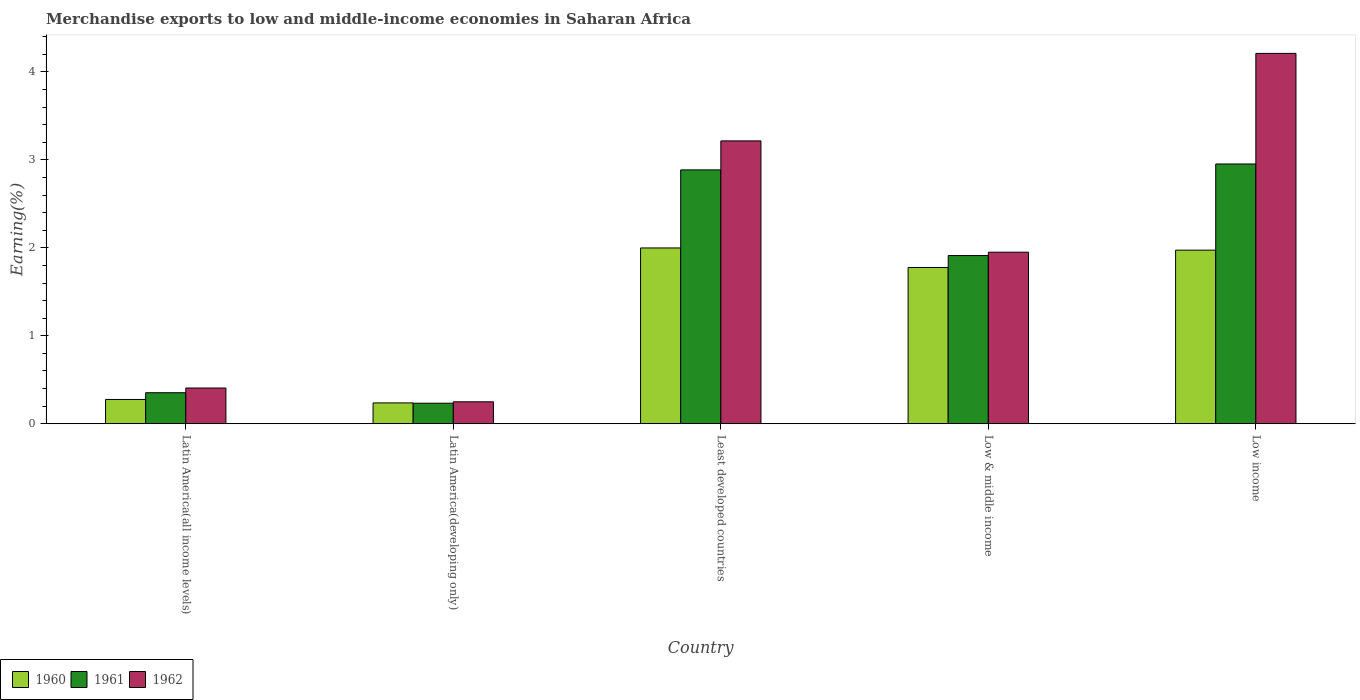How many different coloured bars are there?
Your answer should be very brief. 3. Are the number of bars on each tick of the X-axis equal?
Ensure brevity in your answer.  Yes. What is the label of the 1st group of bars from the left?
Provide a short and direct response. Latin America(all income levels). What is the percentage of amount earned from merchandise exports in 1962 in Least developed countries?
Keep it short and to the point. 3.22. Across all countries, what is the maximum percentage of amount earned from merchandise exports in 1962?
Ensure brevity in your answer.  4.21. Across all countries, what is the minimum percentage of amount earned from merchandise exports in 1960?
Your answer should be compact. 0.24. In which country was the percentage of amount earned from merchandise exports in 1962 maximum?
Ensure brevity in your answer.  Low income. In which country was the percentage of amount earned from merchandise exports in 1960 minimum?
Ensure brevity in your answer.  Latin America(developing only). What is the total percentage of amount earned from merchandise exports in 1960 in the graph?
Offer a very short reply. 6.26. What is the difference between the percentage of amount earned from merchandise exports in 1961 in Latin America(all income levels) and that in Low income?
Your response must be concise. -2.6. What is the difference between the percentage of amount earned from merchandise exports in 1961 in Least developed countries and the percentage of amount earned from merchandise exports in 1962 in Low & middle income?
Your response must be concise. 0.94. What is the average percentage of amount earned from merchandise exports in 1961 per country?
Offer a very short reply. 1.67. What is the difference between the percentage of amount earned from merchandise exports of/in 1961 and percentage of amount earned from merchandise exports of/in 1960 in Least developed countries?
Your answer should be very brief. 0.89. What is the ratio of the percentage of amount earned from merchandise exports in 1960 in Latin America(all income levels) to that in Low income?
Offer a very short reply. 0.14. Is the percentage of amount earned from merchandise exports in 1961 in Latin America(all income levels) less than that in Low & middle income?
Make the answer very short. Yes. What is the difference between the highest and the second highest percentage of amount earned from merchandise exports in 1962?
Your answer should be very brief. -1.27. What is the difference between the highest and the lowest percentage of amount earned from merchandise exports in 1961?
Your response must be concise. 2.72. Is the sum of the percentage of amount earned from merchandise exports in 1961 in Latin America(all income levels) and Low income greater than the maximum percentage of amount earned from merchandise exports in 1960 across all countries?
Ensure brevity in your answer.  Yes. What does the 3rd bar from the left in Latin America(developing only) represents?
Offer a terse response. 1962. Is it the case that in every country, the sum of the percentage of amount earned from merchandise exports in 1960 and percentage of amount earned from merchandise exports in 1962 is greater than the percentage of amount earned from merchandise exports in 1961?
Keep it short and to the point. Yes. Are all the bars in the graph horizontal?
Ensure brevity in your answer.  No. Does the graph contain any zero values?
Your answer should be very brief. No. What is the title of the graph?
Your response must be concise. Merchandise exports to low and middle-income economies in Saharan Africa. Does "1989" appear as one of the legend labels in the graph?
Make the answer very short. No. What is the label or title of the X-axis?
Keep it short and to the point. Country. What is the label or title of the Y-axis?
Ensure brevity in your answer.  Earning(%). What is the Earning(%) of 1960 in Latin America(all income levels)?
Provide a short and direct response. 0.28. What is the Earning(%) of 1961 in Latin America(all income levels)?
Offer a very short reply. 0.35. What is the Earning(%) in 1962 in Latin America(all income levels)?
Your response must be concise. 0.41. What is the Earning(%) of 1960 in Latin America(developing only)?
Ensure brevity in your answer.  0.24. What is the Earning(%) in 1961 in Latin America(developing only)?
Provide a short and direct response. 0.23. What is the Earning(%) in 1962 in Latin America(developing only)?
Keep it short and to the point. 0.25. What is the Earning(%) of 1960 in Least developed countries?
Offer a terse response. 2. What is the Earning(%) of 1961 in Least developed countries?
Provide a succinct answer. 2.89. What is the Earning(%) of 1962 in Least developed countries?
Ensure brevity in your answer.  3.22. What is the Earning(%) in 1960 in Low & middle income?
Your answer should be very brief. 1.78. What is the Earning(%) in 1961 in Low & middle income?
Provide a succinct answer. 1.91. What is the Earning(%) in 1962 in Low & middle income?
Provide a succinct answer. 1.95. What is the Earning(%) in 1960 in Low income?
Your answer should be very brief. 1.97. What is the Earning(%) in 1961 in Low income?
Ensure brevity in your answer.  2.95. What is the Earning(%) of 1962 in Low income?
Provide a succinct answer. 4.21. Across all countries, what is the maximum Earning(%) of 1960?
Provide a succinct answer. 2. Across all countries, what is the maximum Earning(%) of 1961?
Provide a short and direct response. 2.95. Across all countries, what is the maximum Earning(%) in 1962?
Your answer should be compact. 4.21. Across all countries, what is the minimum Earning(%) in 1960?
Your answer should be very brief. 0.24. Across all countries, what is the minimum Earning(%) of 1961?
Ensure brevity in your answer.  0.23. Across all countries, what is the minimum Earning(%) of 1962?
Ensure brevity in your answer.  0.25. What is the total Earning(%) in 1960 in the graph?
Your answer should be very brief. 6.26. What is the total Earning(%) of 1961 in the graph?
Provide a short and direct response. 8.34. What is the total Earning(%) of 1962 in the graph?
Make the answer very short. 10.03. What is the difference between the Earning(%) in 1960 in Latin America(all income levels) and that in Latin America(developing only)?
Your answer should be compact. 0.04. What is the difference between the Earning(%) in 1961 in Latin America(all income levels) and that in Latin America(developing only)?
Offer a terse response. 0.12. What is the difference between the Earning(%) in 1962 in Latin America(all income levels) and that in Latin America(developing only)?
Your answer should be compact. 0.16. What is the difference between the Earning(%) of 1960 in Latin America(all income levels) and that in Least developed countries?
Provide a short and direct response. -1.72. What is the difference between the Earning(%) of 1961 in Latin America(all income levels) and that in Least developed countries?
Your answer should be very brief. -2.53. What is the difference between the Earning(%) in 1962 in Latin America(all income levels) and that in Least developed countries?
Provide a succinct answer. -2.81. What is the difference between the Earning(%) in 1960 in Latin America(all income levels) and that in Low & middle income?
Your answer should be compact. -1.5. What is the difference between the Earning(%) of 1961 in Latin America(all income levels) and that in Low & middle income?
Ensure brevity in your answer.  -1.56. What is the difference between the Earning(%) of 1962 in Latin America(all income levels) and that in Low & middle income?
Your response must be concise. -1.54. What is the difference between the Earning(%) in 1960 in Latin America(all income levels) and that in Low income?
Keep it short and to the point. -1.7. What is the difference between the Earning(%) in 1961 in Latin America(all income levels) and that in Low income?
Provide a short and direct response. -2.6. What is the difference between the Earning(%) in 1962 in Latin America(all income levels) and that in Low income?
Keep it short and to the point. -3.8. What is the difference between the Earning(%) in 1960 in Latin America(developing only) and that in Least developed countries?
Offer a terse response. -1.76. What is the difference between the Earning(%) in 1961 in Latin America(developing only) and that in Least developed countries?
Your response must be concise. -2.65. What is the difference between the Earning(%) of 1962 in Latin America(developing only) and that in Least developed countries?
Give a very brief answer. -2.97. What is the difference between the Earning(%) of 1960 in Latin America(developing only) and that in Low & middle income?
Your answer should be compact. -1.54. What is the difference between the Earning(%) in 1961 in Latin America(developing only) and that in Low & middle income?
Give a very brief answer. -1.68. What is the difference between the Earning(%) of 1962 in Latin America(developing only) and that in Low & middle income?
Provide a succinct answer. -1.7. What is the difference between the Earning(%) in 1960 in Latin America(developing only) and that in Low income?
Your answer should be very brief. -1.74. What is the difference between the Earning(%) in 1961 in Latin America(developing only) and that in Low income?
Your answer should be compact. -2.72. What is the difference between the Earning(%) in 1962 in Latin America(developing only) and that in Low income?
Offer a very short reply. -3.96. What is the difference between the Earning(%) in 1960 in Least developed countries and that in Low & middle income?
Offer a very short reply. 0.22. What is the difference between the Earning(%) of 1961 in Least developed countries and that in Low & middle income?
Provide a succinct answer. 0.97. What is the difference between the Earning(%) in 1962 in Least developed countries and that in Low & middle income?
Make the answer very short. 1.27. What is the difference between the Earning(%) in 1960 in Least developed countries and that in Low income?
Provide a short and direct response. 0.03. What is the difference between the Earning(%) of 1961 in Least developed countries and that in Low income?
Provide a succinct answer. -0.07. What is the difference between the Earning(%) of 1962 in Least developed countries and that in Low income?
Provide a succinct answer. -0.99. What is the difference between the Earning(%) of 1960 in Low & middle income and that in Low income?
Offer a very short reply. -0.2. What is the difference between the Earning(%) of 1961 in Low & middle income and that in Low income?
Keep it short and to the point. -1.04. What is the difference between the Earning(%) in 1962 in Low & middle income and that in Low income?
Offer a terse response. -2.26. What is the difference between the Earning(%) in 1960 in Latin America(all income levels) and the Earning(%) in 1961 in Latin America(developing only)?
Your answer should be compact. 0.04. What is the difference between the Earning(%) of 1960 in Latin America(all income levels) and the Earning(%) of 1962 in Latin America(developing only)?
Ensure brevity in your answer.  0.03. What is the difference between the Earning(%) in 1961 in Latin America(all income levels) and the Earning(%) in 1962 in Latin America(developing only)?
Ensure brevity in your answer.  0.1. What is the difference between the Earning(%) of 1960 in Latin America(all income levels) and the Earning(%) of 1961 in Least developed countries?
Offer a terse response. -2.61. What is the difference between the Earning(%) of 1960 in Latin America(all income levels) and the Earning(%) of 1962 in Least developed countries?
Your response must be concise. -2.94. What is the difference between the Earning(%) of 1961 in Latin America(all income levels) and the Earning(%) of 1962 in Least developed countries?
Provide a succinct answer. -2.86. What is the difference between the Earning(%) in 1960 in Latin America(all income levels) and the Earning(%) in 1961 in Low & middle income?
Your answer should be compact. -1.64. What is the difference between the Earning(%) of 1960 in Latin America(all income levels) and the Earning(%) of 1962 in Low & middle income?
Provide a short and direct response. -1.67. What is the difference between the Earning(%) of 1961 in Latin America(all income levels) and the Earning(%) of 1962 in Low & middle income?
Your response must be concise. -1.6. What is the difference between the Earning(%) of 1960 in Latin America(all income levels) and the Earning(%) of 1961 in Low income?
Give a very brief answer. -2.68. What is the difference between the Earning(%) in 1960 in Latin America(all income levels) and the Earning(%) in 1962 in Low income?
Make the answer very short. -3.94. What is the difference between the Earning(%) of 1961 in Latin America(all income levels) and the Earning(%) of 1962 in Low income?
Your answer should be compact. -3.86. What is the difference between the Earning(%) in 1960 in Latin America(developing only) and the Earning(%) in 1961 in Least developed countries?
Provide a short and direct response. -2.65. What is the difference between the Earning(%) of 1960 in Latin America(developing only) and the Earning(%) of 1962 in Least developed countries?
Make the answer very short. -2.98. What is the difference between the Earning(%) in 1961 in Latin America(developing only) and the Earning(%) in 1962 in Least developed countries?
Your answer should be very brief. -2.98. What is the difference between the Earning(%) in 1960 in Latin America(developing only) and the Earning(%) in 1961 in Low & middle income?
Give a very brief answer. -1.68. What is the difference between the Earning(%) in 1960 in Latin America(developing only) and the Earning(%) in 1962 in Low & middle income?
Your answer should be very brief. -1.71. What is the difference between the Earning(%) in 1961 in Latin America(developing only) and the Earning(%) in 1962 in Low & middle income?
Make the answer very short. -1.72. What is the difference between the Earning(%) in 1960 in Latin America(developing only) and the Earning(%) in 1961 in Low income?
Give a very brief answer. -2.72. What is the difference between the Earning(%) in 1960 in Latin America(developing only) and the Earning(%) in 1962 in Low income?
Give a very brief answer. -3.97. What is the difference between the Earning(%) in 1961 in Latin America(developing only) and the Earning(%) in 1962 in Low income?
Your answer should be compact. -3.98. What is the difference between the Earning(%) of 1960 in Least developed countries and the Earning(%) of 1961 in Low & middle income?
Your response must be concise. 0.09. What is the difference between the Earning(%) of 1960 in Least developed countries and the Earning(%) of 1962 in Low & middle income?
Offer a very short reply. 0.05. What is the difference between the Earning(%) in 1961 in Least developed countries and the Earning(%) in 1962 in Low & middle income?
Offer a terse response. 0.94. What is the difference between the Earning(%) in 1960 in Least developed countries and the Earning(%) in 1961 in Low income?
Give a very brief answer. -0.95. What is the difference between the Earning(%) of 1960 in Least developed countries and the Earning(%) of 1962 in Low income?
Ensure brevity in your answer.  -2.21. What is the difference between the Earning(%) in 1961 in Least developed countries and the Earning(%) in 1962 in Low income?
Offer a terse response. -1.32. What is the difference between the Earning(%) of 1960 in Low & middle income and the Earning(%) of 1961 in Low income?
Keep it short and to the point. -1.18. What is the difference between the Earning(%) of 1960 in Low & middle income and the Earning(%) of 1962 in Low income?
Ensure brevity in your answer.  -2.43. What is the difference between the Earning(%) in 1961 in Low & middle income and the Earning(%) in 1962 in Low income?
Offer a terse response. -2.3. What is the average Earning(%) of 1960 per country?
Offer a very short reply. 1.25. What is the average Earning(%) in 1961 per country?
Your response must be concise. 1.67. What is the average Earning(%) of 1962 per country?
Provide a short and direct response. 2.01. What is the difference between the Earning(%) in 1960 and Earning(%) in 1961 in Latin America(all income levels)?
Your answer should be compact. -0.08. What is the difference between the Earning(%) in 1960 and Earning(%) in 1962 in Latin America(all income levels)?
Your answer should be compact. -0.13. What is the difference between the Earning(%) in 1961 and Earning(%) in 1962 in Latin America(all income levels)?
Give a very brief answer. -0.05. What is the difference between the Earning(%) of 1960 and Earning(%) of 1961 in Latin America(developing only)?
Keep it short and to the point. 0. What is the difference between the Earning(%) of 1960 and Earning(%) of 1962 in Latin America(developing only)?
Offer a very short reply. -0.01. What is the difference between the Earning(%) in 1961 and Earning(%) in 1962 in Latin America(developing only)?
Offer a terse response. -0.02. What is the difference between the Earning(%) in 1960 and Earning(%) in 1961 in Least developed countries?
Give a very brief answer. -0.89. What is the difference between the Earning(%) in 1960 and Earning(%) in 1962 in Least developed countries?
Your answer should be compact. -1.22. What is the difference between the Earning(%) in 1961 and Earning(%) in 1962 in Least developed countries?
Your answer should be compact. -0.33. What is the difference between the Earning(%) of 1960 and Earning(%) of 1961 in Low & middle income?
Your response must be concise. -0.14. What is the difference between the Earning(%) of 1960 and Earning(%) of 1962 in Low & middle income?
Ensure brevity in your answer.  -0.17. What is the difference between the Earning(%) in 1961 and Earning(%) in 1962 in Low & middle income?
Keep it short and to the point. -0.04. What is the difference between the Earning(%) in 1960 and Earning(%) in 1961 in Low income?
Provide a short and direct response. -0.98. What is the difference between the Earning(%) in 1960 and Earning(%) in 1962 in Low income?
Your answer should be very brief. -2.24. What is the difference between the Earning(%) of 1961 and Earning(%) of 1962 in Low income?
Offer a terse response. -1.26. What is the ratio of the Earning(%) of 1960 in Latin America(all income levels) to that in Latin America(developing only)?
Give a very brief answer. 1.17. What is the ratio of the Earning(%) of 1961 in Latin America(all income levels) to that in Latin America(developing only)?
Offer a very short reply. 1.51. What is the ratio of the Earning(%) of 1962 in Latin America(all income levels) to that in Latin America(developing only)?
Ensure brevity in your answer.  1.63. What is the ratio of the Earning(%) in 1960 in Latin America(all income levels) to that in Least developed countries?
Make the answer very short. 0.14. What is the ratio of the Earning(%) in 1961 in Latin America(all income levels) to that in Least developed countries?
Ensure brevity in your answer.  0.12. What is the ratio of the Earning(%) of 1962 in Latin America(all income levels) to that in Least developed countries?
Offer a terse response. 0.13. What is the ratio of the Earning(%) in 1960 in Latin America(all income levels) to that in Low & middle income?
Your answer should be very brief. 0.16. What is the ratio of the Earning(%) of 1961 in Latin America(all income levels) to that in Low & middle income?
Provide a succinct answer. 0.18. What is the ratio of the Earning(%) in 1962 in Latin America(all income levels) to that in Low & middle income?
Your answer should be very brief. 0.21. What is the ratio of the Earning(%) of 1960 in Latin America(all income levels) to that in Low income?
Provide a short and direct response. 0.14. What is the ratio of the Earning(%) of 1961 in Latin America(all income levels) to that in Low income?
Offer a very short reply. 0.12. What is the ratio of the Earning(%) of 1962 in Latin America(all income levels) to that in Low income?
Provide a succinct answer. 0.1. What is the ratio of the Earning(%) of 1960 in Latin America(developing only) to that in Least developed countries?
Make the answer very short. 0.12. What is the ratio of the Earning(%) of 1961 in Latin America(developing only) to that in Least developed countries?
Offer a terse response. 0.08. What is the ratio of the Earning(%) in 1962 in Latin America(developing only) to that in Least developed countries?
Your answer should be very brief. 0.08. What is the ratio of the Earning(%) of 1960 in Latin America(developing only) to that in Low & middle income?
Ensure brevity in your answer.  0.13. What is the ratio of the Earning(%) of 1961 in Latin America(developing only) to that in Low & middle income?
Provide a succinct answer. 0.12. What is the ratio of the Earning(%) of 1962 in Latin America(developing only) to that in Low & middle income?
Provide a short and direct response. 0.13. What is the ratio of the Earning(%) of 1960 in Latin America(developing only) to that in Low income?
Keep it short and to the point. 0.12. What is the ratio of the Earning(%) in 1961 in Latin America(developing only) to that in Low income?
Your answer should be compact. 0.08. What is the ratio of the Earning(%) of 1962 in Latin America(developing only) to that in Low income?
Provide a succinct answer. 0.06. What is the ratio of the Earning(%) in 1961 in Least developed countries to that in Low & middle income?
Your answer should be very brief. 1.51. What is the ratio of the Earning(%) of 1962 in Least developed countries to that in Low & middle income?
Ensure brevity in your answer.  1.65. What is the ratio of the Earning(%) of 1960 in Least developed countries to that in Low income?
Offer a terse response. 1.01. What is the ratio of the Earning(%) of 1961 in Least developed countries to that in Low income?
Your answer should be very brief. 0.98. What is the ratio of the Earning(%) of 1962 in Least developed countries to that in Low income?
Provide a succinct answer. 0.76. What is the ratio of the Earning(%) in 1960 in Low & middle income to that in Low income?
Keep it short and to the point. 0.9. What is the ratio of the Earning(%) in 1961 in Low & middle income to that in Low income?
Make the answer very short. 0.65. What is the ratio of the Earning(%) of 1962 in Low & middle income to that in Low income?
Your answer should be very brief. 0.46. What is the difference between the highest and the second highest Earning(%) in 1960?
Your answer should be very brief. 0.03. What is the difference between the highest and the second highest Earning(%) in 1961?
Keep it short and to the point. 0.07. What is the difference between the highest and the second highest Earning(%) in 1962?
Ensure brevity in your answer.  0.99. What is the difference between the highest and the lowest Earning(%) in 1960?
Your response must be concise. 1.76. What is the difference between the highest and the lowest Earning(%) in 1961?
Provide a short and direct response. 2.72. What is the difference between the highest and the lowest Earning(%) of 1962?
Provide a succinct answer. 3.96. 